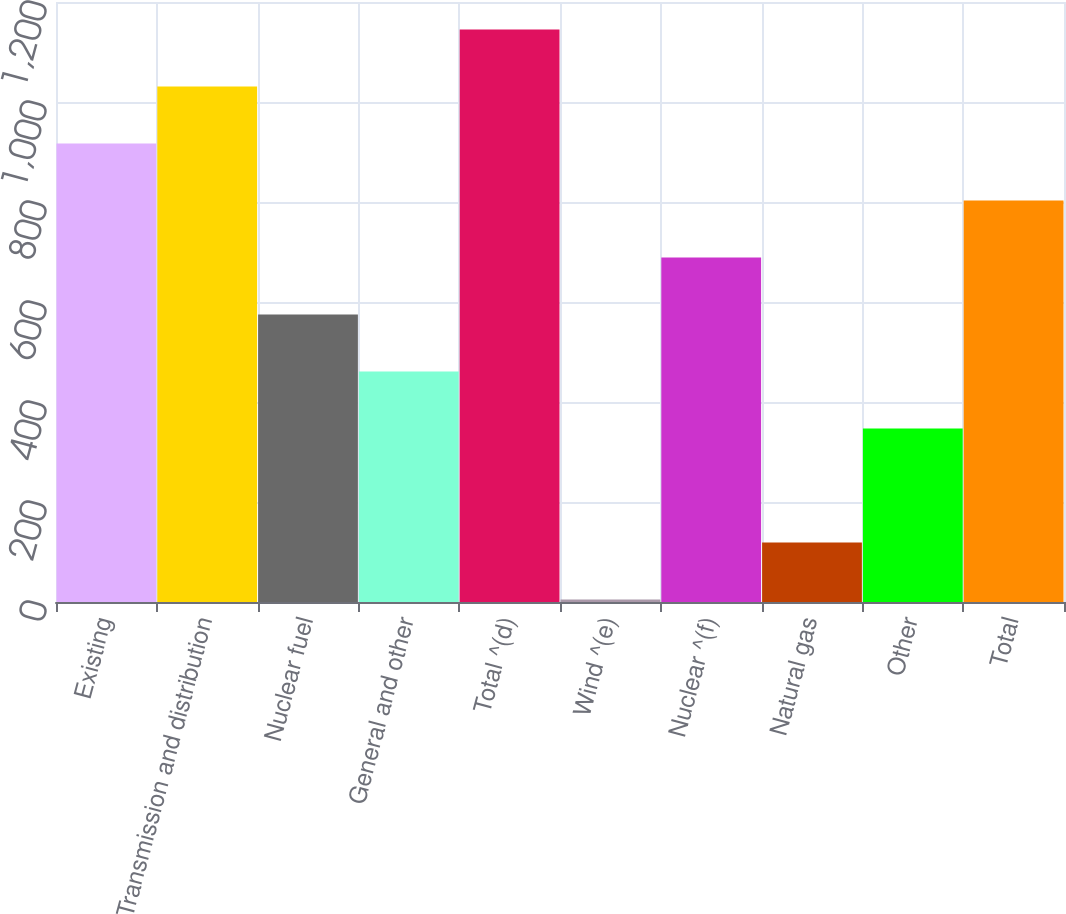Convert chart to OTSL. <chart><loc_0><loc_0><loc_500><loc_500><bar_chart><fcel>Existing<fcel>Transmission and distribution<fcel>Nuclear fuel<fcel>General and other<fcel>Total ^(d)<fcel>Wind ^(e)<fcel>Nuclear ^(f)<fcel>Natural gas<fcel>Other<fcel>Total<nl><fcel>917<fcel>1031<fcel>575<fcel>461<fcel>1145<fcel>5<fcel>689<fcel>119<fcel>347<fcel>803<nl></chart> 